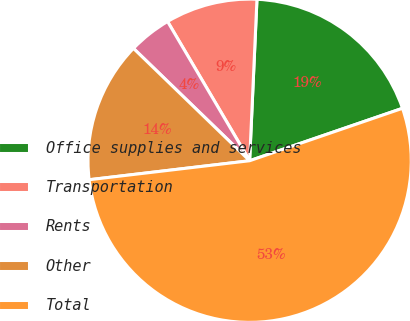Convert chart to OTSL. <chart><loc_0><loc_0><loc_500><loc_500><pie_chart><fcel>Office supplies and services<fcel>Transportation<fcel>Rents<fcel>Other<fcel>Total<nl><fcel>19.02%<fcel>9.2%<fcel>4.29%<fcel>14.11%<fcel>53.39%<nl></chart> 